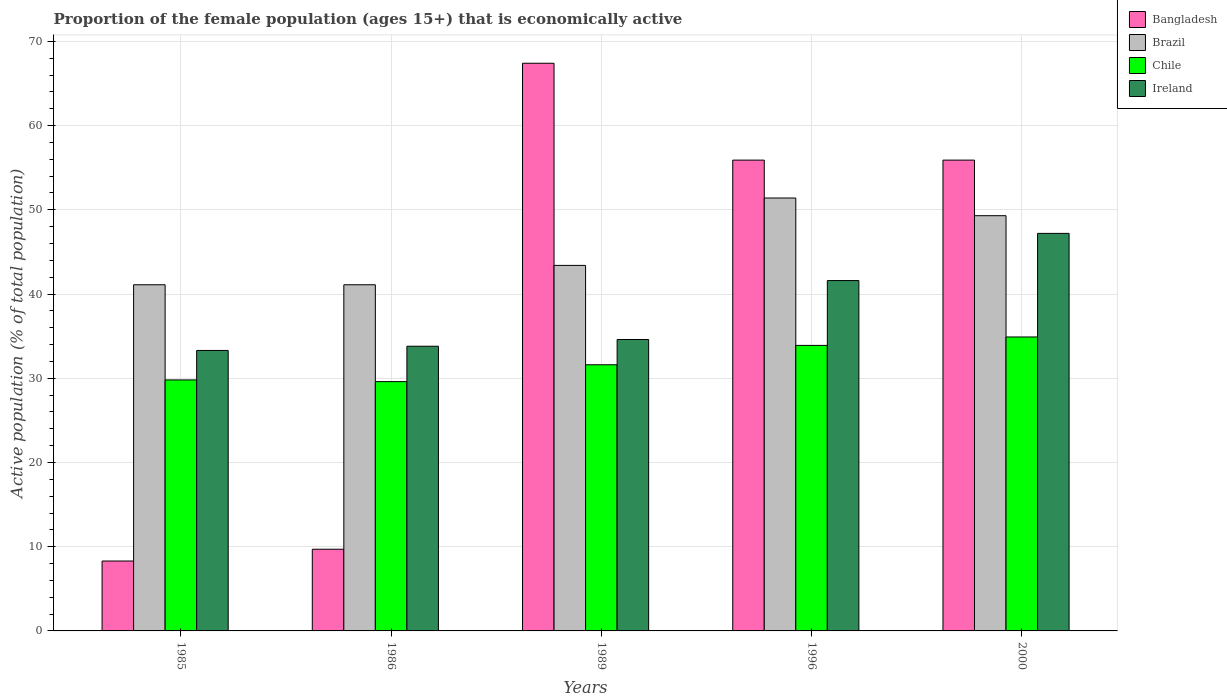How many different coloured bars are there?
Give a very brief answer. 4. How many groups of bars are there?
Your answer should be compact. 5. Are the number of bars on each tick of the X-axis equal?
Offer a terse response. Yes. How many bars are there on the 5th tick from the left?
Provide a short and direct response. 4. What is the proportion of the female population that is economically active in Brazil in 1989?
Give a very brief answer. 43.4. Across all years, what is the maximum proportion of the female population that is economically active in Chile?
Keep it short and to the point. 34.9. Across all years, what is the minimum proportion of the female population that is economically active in Ireland?
Your response must be concise. 33.3. In which year was the proportion of the female population that is economically active in Chile maximum?
Ensure brevity in your answer.  2000. In which year was the proportion of the female population that is economically active in Ireland minimum?
Your answer should be compact. 1985. What is the total proportion of the female population that is economically active in Bangladesh in the graph?
Ensure brevity in your answer.  197.2. What is the difference between the proportion of the female population that is economically active in Brazil in 1989 and that in 2000?
Your response must be concise. -5.9. What is the difference between the proportion of the female population that is economically active in Brazil in 2000 and the proportion of the female population that is economically active in Chile in 1985?
Offer a very short reply. 19.5. What is the average proportion of the female population that is economically active in Brazil per year?
Your answer should be compact. 45.26. In the year 1985, what is the difference between the proportion of the female population that is economically active in Brazil and proportion of the female population that is economically active in Bangladesh?
Provide a succinct answer. 32.8. What is the ratio of the proportion of the female population that is economically active in Brazil in 1985 to that in 1986?
Your response must be concise. 1. Is the proportion of the female population that is economically active in Ireland in 1985 less than that in 1986?
Provide a short and direct response. Yes. What is the difference between the highest and the second highest proportion of the female population that is economically active in Bangladesh?
Make the answer very short. 11.5. What is the difference between the highest and the lowest proportion of the female population that is economically active in Brazil?
Your answer should be very brief. 10.3. Is the sum of the proportion of the female population that is economically active in Brazil in 1985 and 1996 greater than the maximum proportion of the female population that is economically active in Chile across all years?
Your answer should be compact. Yes. What does the 3rd bar from the left in 1985 represents?
Give a very brief answer. Chile. What does the 2nd bar from the right in 1989 represents?
Offer a terse response. Chile. Is it the case that in every year, the sum of the proportion of the female population that is economically active in Chile and proportion of the female population that is economically active in Bangladesh is greater than the proportion of the female population that is economically active in Brazil?
Make the answer very short. No. How many bars are there?
Ensure brevity in your answer.  20. Are all the bars in the graph horizontal?
Keep it short and to the point. No. Does the graph contain grids?
Your response must be concise. Yes. What is the title of the graph?
Your response must be concise. Proportion of the female population (ages 15+) that is economically active. Does "St. Martin (French part)" appear as one of the legend labels in the graph?
Make the answer very short. No. What is the label or title of the X-axis?
Give a very brief answer. Years. What is the label or title of the Y-axis?
Ensure brevity in your answer.  Active population (% of total population). What is the Active population (% of total population) in Bangladesh in 1985?
Make the answer very short. 8.3. What is the Active population (% of total population) in Brazil in 1985?
Give a very brief answer. 41.1. What is the Active population (% of total population) in Chile in 1985?
Make the answer very short. 29.8. What is the Active population (% of total population) of Ireland in 1985?
Provide a short and direct response. 33.3. What is the Active population (% of total population) of Bangladesh in 1986?
Your answer should be compact. 9.7. What is the Active population (% of total population) in Brazil in 1986?
Your answer should be very brief. 41.1. What is the Active population (% of total population) of Chile in 1986?
Your answer should be compact. 29.6. What is the Active population (% of total population) in Ireland in 1986?
Keep it short and to the point. 33.8. What is the Active population (% of total population) in Bangladesh in 1989?
Provide a succinct answer. 67.4. What is the Active population (% of total population) of Brazil in 1989?
Keep it short and to the point. 43.4. What is the Active population (% of total population) in Chile in 1989?
Keep it short and to the point. 31.6. What is the Active population (% of total population) in Ireland in 1989?
Your response must be concise. 34.6. What is the Active population (% of total population) in Bangladesh in 1996?
Keep it short and to the point. 55.9. What is the Active population (% of total population) in Brazil in 1996?
Your answer should be compact. 51.4. What is the Active population (% of total population) in Chile in 1996?
Offer a terse response. 33.9. What is the Active population (% of total population) of Ireland in 1996?
Offer a terse response. 41.6. What is the Active population (% of total population) of Bangladesh in 2000?
Offer a very short reply. 55.9. What is the Active population (% of total population) of Brazil in 2000?
Ensure brevity in your answer.  49.3. What is the Active population (% of total population) in Chile in 2000?
Give a very brief answer. 34.9. What is the Active population (% of total population) of Ireland in 2000?
Make the answer very short. 47.2. Across all years, what is the maximum Active population (% of total population) in Bangladesh?
Make the answer very short. 67.4. Across all years, what is the maximum Active population (% of total population) of Brazil?
Your response must be concise. 51.4. Across all years, what is the maximum Active population (% of total population) of Chile?
Your response must be concise. 34.9. Across all years, what is the maximum Active population (% of total population) in Ireland?
Your response must be concise. 47.2. Across all years, what is the minimum Active population (% of total population) in Bangladesh?
Give a very brief answer. 8.3. Across all years, what is the minimum Active population (% of total population) in Brazil?
Your answer should be very brief. 41.1. Across all years, what is the minimum Active population (% of total population) of Chile?
Give a very brief answer. 29.6. Across all years, what is the minimum Active population (% of total population) in Ireland?
Your answer should be compact. 33.3. What is the total Active population (% of total population) of Bangladesh in the graph?
Offer a terse response. 197.2. What is the total Active population (% of total population) of Brazil in the graph?
Ensure brevity in your answer.  226.3. What is the total Active population (% of total population) of Chile in the graph?
Provide a short and direct response. 159.8. What is the total Active population (% of total population) of Ireland in the graph?
Your answer should be very brief. 190.5. What is the difference between the Active population (% of total population) of Chile in 1985 and that in 1986?
Offer a terse response. 0.2. What is the difference between the Active population (% of total population) of Bangladesh in 1985 and that in 1989?
Your answer should be very brief. -59.1. What is the difference between the Active population (% of total population) of Ireland in 1985 and that in 1989?
Your response must be concise. -1.3. What is the difference between the Active population (% of total population) of Bangladesh in 1985 and that in 1996?
Offer a terse response. -47.6. What is the difference between the Active population (% of total population) of Chile in 1985 and that in 1996?
Offer a very short reply. -4.1. What is the difference between the Active population (% of total population) in Ireland in 1985 and that in 1996?
Your answer should be compact. -8.3. What is the difference between the Active population (% of total population) of Bangladesh in 1985 and that in 2000?
Give a very brief answer. -47.6. What is the difference between the Active population (% of total population) of Chile in 1985 and that in 2000?
Offer a very short reply. -5.1. What is the difference between the Active population (% of total population) in Bangladesh in 1986 and that in 1989?
Provide a short and direct response. -57.7. What is the difference between the Active population (% of total population) of Brazil in 1986 and that in 1989?
Keep it short and to the point. -2.3. What is the difference between the Active population (% of total population) in Bangladesh in 1986 and that in 1996?
Your answer should be compact. -46.2. What is the difference between the Active population (% of total population) in Ireland in 1986 and that in 1996?
Provide a short and direct response. -7.8. What is the difference between the Active population (% of total population) in Bangladesh in 1986 and that in 2000?
Make the answer very short. -46.2. What is the difference between the Active population (% of total population) in Brazil in 1986 and that in 2000?
Provide a succinct answer. -8.2. What is the difference between the Active population (% of total population) of Chile in 1989 and that in 1996?
Give a very brief answer. -2.3. What is the difference between the Active population (% of total population) of Ireland in 1989 and that in 1996?
Your answer should be very brief. -7. What is the difference between the Active population (% of total population) in Bangladesh in 1989 and that in 2000?
Ensure brevity in your answer.  11.5. What is the difference between the Active population (% of total population) in Brazil in 1989 and that in 2000?
Give a very brief answer. -5.9. What is the difference between the Active population (% of total population) of Ireland in 1989 and that in 2000?
Your answer should be very brief. -12.6. What is the difference between the Active population (% of total population) in Bangladesh in 1996 and that in 2000?
Ensure brevity in your answer.  0. What is the difference between the Active population (% of total population) of Chile in 1996 and that in 2000?
Your answer should be compact. -1. What is the difference between the Active population (% of total population) in Ireland in 1996 and that in 2000?
Ensure brevity in your answer.  -5.6. What is the difference between the Active population (% of total population) in Bangladesh in 1985 and the Active population (% of total population) in Brazil in 1986?
Your response must be concise. -32.8. What is the difference between the Active population (% of total population) of Bangladesh in 1985 and the Active population (% of total population) of Chile in 1986?
Offer a very short reply. -21.3. What is the difference between the Active population (% of total population) of Bangladesh in 1985 and the Active population (% of total population) of Ireland in 1986?
Your response must be concise. -25.5. What is the difference between the Active population (% of total population) of Brazil in 1985 and the Active population (% of total population) of Chile in 1986?
Your answer should be compact. 11.5. What is the difference between the Active population (% of total population) of Bangladesh in 1985 and the Active population (% of total population) of Brazil in 1989?
Provide a succinct answer. -35.1. What is the difference between the Active population (% of total population) of Bangladesh in 1985 and the Active population (% of total population) of Chile in 1989?
Offer a terse response. -23.3. What is the difference between the Active population (% of total population) in Bangladesh in 1985 and the Active population (% of total population) in Ireland in 1989?
Give a very brief answer. -26.3. What is the difference between the Active population (% of total population) in Brazil in 1985 and the Active population (% of total population) in Chile in 1989?
Provide a short and direct response. 9.5. What is the difference between the Active population (% of total population) of Brazil in 1985 and the Active population (% of total population) of Ireland in 1989?
Your answer should be very brief. 6.5. What is the difference between the Active population (% of total population) in Chile in 1985 and the Active population (% of total population) in Ireland in 1989?
Keep it short and to the point. -4.8. What is the difference between the Active population (% of total population) of Bangladesh in 1985 and the Active population (% of total population) of Brazil in 1996?
Make the answer very short. -43.1. What is the difference between the Active population (% of total population) in Bangladesh in 1985 and the Active population (% of total population) in Chile in 1996?
Your answer should be very brief. -25.6. What is the difference between the Active population (% of total population) of Bangladesh in 1985 and the Active population (% of total population) of Ireland in 1996?
Your answer should be very brief. -33.3. What is the difference between the Active population (% of total population) of Brazil in 1985 and the Active population (% of total population) of Chile in 1996?
Your answer should be compact. 7.2. What is the difference between the Active population (% of total population) of Brazil in 1985 and the Active population (% of total population) of Ireland in 1996?
Give a very brief answer. -0.5. What is the difference between the Active population (% of total population) of Chile in 1985 and the Active population (% of total population) of Ireland in 1996?
Make the answer very short. -11.8. What is the difference between the Active population (% of total population) of Bangladesh in 1985 and the Active population (% of total population) of Brazil in 2000?
Keep it short and to the point. -41. What is the difference between the Active population (% of total population) of Bangladesh in 1985 and the Active population (% of total population) of Chile in 2000?
Give a very brief answer. -26.6. What is the difference between the Active population (% of total population) in Bangladesh in 1985 and the Active population (% of total population) in Ireland in 2000?
Offer a very short reply. -38.9. What is the difference between the Active population (% of total population) of Brazil in 1985 and the Active population (% of total population) of Ireland in 2000?
Your answer should be compact. -6.1. What is the difference between the Active population (% of total population) in Chile in 1985 and the Active population (% of total population) in Ireland in 2000?
Offer a terse response. -17.4. What is the difference between the Active population (% of total population) of Bangladesh in 1986 and the Active population (% of total population) of Brazil in 1989?
Provide a short and direct response. -33.7. What is the difference between the Active population (% of total population) of Bangladesh in 1986 and the Active population (% of total population) of Chile in 1989?
Provide a short and direct response. -21.9. What is the difference between the Active population (% of total population) of Bangladesh in 1986 and the Active population (% of total population) of Ireland in 1989?
Offer a very short reply. -24.9. What is the difference between the Active population (% of total population) of Brazil in 1986 and the Active population (% of total population) of Ireland in 1989?
Give a very brief answer. 6.5. What is the difference between the Active population (% of total population) in Chile in 1986 and the Active population (% of total population) in Ireland in 1989?
Provide a short and direct response. -5. What is the difference between the Active population (% of total population) in Bangladesh in 1986 and the Active population (% of total population) in Brazil in 1996?
Give a very brief answer. -41.7. What is the difference between the Active population (% of total population) of Bangladesh in 1986 and the Active population (% of total population) of Chile in 1996?
Give a very brief answer. -24.2. What is the difference between the Active population (% of total population) of Bangladesh in 1986 and the Active population (% of total population) of Ireland in 1996?
Offer a terse response. -31.9. What is the difference between the Active population (% of total population) of Brazil in 1986 and the Active population (% of total population) of Chile in 1996?
Your response must be concise. 7.2. What is the difference between the Active population (% of total population) of Bangladesh in 1986 and the Active population (% of total population) of Brazil in 2000?
Give a very brief answer. -39.6. What is the difference between the Active population (% of total population) of Bangladesh in 1986 and the Active population (% of total population) of Chile in 2000?
Keep it short and to the point. -25.2. What is the difference between the Active population (% of total population) of Bangladesh in 1986 and the Active population (% of total population) of Ireland in 2000?
Offer a very short reply. -37.5. What is the difference between the Active population (% of total population) of Brazil in 1986 and the Active population (% of total population) of Chile in 2000?
Make the answer very short. 6.2. What is the difference between the Active population (% of total population) in Chile in 1986 and the Active population (% of total population) in Ireland in 2000?
Keep it short and to the point. -17.6. What is the difference between the Active population (% of total population) in Bangladesh in 1989 and the Active population (% of total population) in Chile in 1996?
Provide a succinct answer. 33.5. What is the difference between the Active population (% of total population) in Bangladesh in 1989 and the Active population (% of total population) in Ireland in 1996?
Your response must be concise. 25.8. What is the difference between the Active population (% of total population) of Brazil in 1989 and the Active population (% of total population) of Chile in 1996?
Give a very brief answer. 9.5. What is the difference between the Active population (% of total population) in Chile in 1989 and the Active population (% of total population) in Ireland in 1996?
Provide a succinct answer. -10. What is the difference between the Active population (% of total population) in Bangladesh in 1989 and the Active population (% of total population) in Chile in 2000?
Your response must be concise. 32.5. What is the difference between the Active population (% of total population) in Bangladesh in 1989 and the Active population (% of total population) in Ireland in 2000?
Offer a very short reply. 20.2. What is the difference between the Active population (% of total population) of Brazil in 1989 and the Active population (% of total population) of Ireland in 2000?
Give a very brief answer. -3.8. What is the difference between the Active population (% of total population) in Chile in 1989 and the Active population (% of total population) in Ireland in 2000?
Ensure brevity in your answer.  -15.6. What is the difference between the Active population (% of total population) of Bangladesh in 1996 and the Active population (% of total population) of Brazil in 2000?
Make the answer very short. 6.6. What is the difference between the Active population (% of total population) in Bangladesh in 1996 and the Active population (% of total population) in Chile in 2000?
Provide a succinct answer. 21. What is the difference between the Active population (% of total population) of Bangladesh in 1996 and the Active population (% of total population) of Ireland in 2000?
Ensure brevity in your answer.  8.7. What is the difference between the Active population (% of total population) in Brazil in 1996 and the Active population (% of total population) in Chile in 2000?
Your answer should be compact. 16.5. What is the difference between the Active population (% of total population) of Brazil in 1996 and the Active population (% of total population) of Ireland in 2000?
Make the answer very short. 4.2. What is the difference between the Active population (% of total population) of Chile in 1996 and the Active population (% of total population) of Ireland in 2000?
Give a very brief answer. -13.3. What is the average Active population (% of total population) in Bangladesh per year?
Provide a succinct answer. 39.44. What is the average Active population (% of total population) of Brazil per year?
Your response must be concise. 45.26. What is the average Active population (% of total population) in Chile per year?
Offer a very short reply. 31.96. What is the average Active population (% of total population) in Ireland per year?
Provide a succinct answer. 38.1. In the year 1985, what is the difference between the Active population (% of total population) of Bangladesh and Active population (% of total population) of Brazil?
Keep it short and to the point. -32.8. In the year 1985, what is the difference between the Active population (% of total population) of Bangladesh and Active population (% of total population) of Chile?
Provide a succinct answer. -21.5. In the year 1985, what is the difference between the Active population (% of total population) of Brazil and Active population (% of total population) of Ireland?
Offer a very short reply. 7.8. In the year 1985, what is the difference between the Active population (% of total population) in Chile and Active population (% of total population) in Ireland?
Offer a terse response. -3.5. In the year 1986, what is the difference between the Active population (% of total population) of Bangladesh and Active population (% of total population) of Brazil?
Your response must be concise. -31.4. In the year 1986, what is the difference between the Active population (% of total population) of Bangladesh and Active population (% of total population) of Chile?
Ensure brevity in your answer.  -19.9. In the year 1986, what is the difference between the Active population (% of total population) in Bangladesh and Active population (% of total population) in Ireland?
Your answer should be compact. -24.1. In the year 1986, what is the difference between the Active population (% of total population) in Brazil and Active population (% of total population) in Ireland?
Offer a terse response. 7.3. In the year 1986, what is the difference between the Active population (% of total population) in Chile and Active population (% of total population) in Ireland?
Provide a short and direct response. -4.2. In the year 1989, what is the difference between the Active population (% of total population) in Bangladesh and Active population (% of total population) in Brazil?
Ensure brevity in your answer.  24. In the year 1989, what is the difference between the Active population (% of total population) in Bangladesh and Active population (% of total population) in Chile?
Offer a terse response. 35.8. In the year 1989, what is the difference between the Active population (% of total population) in Bangladesh and Active population (% of total population) in Ireland?
Your response must be concise. 32.8. In the year 1989, what is the difference between the Active population (% of total population) of Chile and Active population (% of total population) of Ireland?
Make the answer very short. -3. In the year 1996, what is the difference between the Active population (% of total population) of Bangladesh and Active population (% of total population) of Chile?
Keep it short and to the point. 22. In the year 1996, what is the difference between the Active population (% of total population) of Bangladesh and Active population (% of total population) of Ireland?
Ensure brevity in your answer.  14.3. In the year 1996, what is the difference between the Active population (% of total population) of Brazil and Active population (% of total population) of Chile?
Ensure brevity in your answer.  17.5. In the year 1996, what is the difference between the Active population (% of total population) in Chile and Active population (% of total population) in Ireland?
Ensure brevity in your answer.  -7.7. In the year 2000, what is the difference between the Active population (% of total population) of Bangladesh and Active population (% of total population) of Brazil?
Your answer should be very brief. 6.6. In the year 2000, what is the difference between the Active population (% of total population) in Brazil and Active population (% of total population) in Ireland?
Provide a succinct answer. 2.1. In the year 2000, what is the difference between the Active population (% of total population) in Chile and Active population (% of total population) in Ireland?
Provide a succinct answer. -12.3. What is the ratio of the Active population (% of total population) in Bangladesh in 1985 to that in 1986?
Ensure brevity in your answer.  0.86. What is the ratio of the Active population (% of total population) of Chile in 1985 to that in 1986?
Give a very brief answer. 1.01. What is the ratio of the Active population (% of total population) in Ireland in 1985 to that in 1986?
Make the answer very short. 0.99. What is the ratio of the Active population (% of total population) of Bangladesh in 1985 to that in 1989?
Your response must be concise. 0.12. What is the ratio of the Active population (% of total population) of Brazil in 1985 to that in 1989?
Offer a terse response. 0.95. What is the ratio of the Active population (% of total population) in Chile in 1985 to that in 1989?
Give a very brief answer. 0.94. What is the ratio of the Active population (% of total population) of Ireland in 1985 to that in 1989?
Keep it short and to the point. 0.96. What is the ratio of the Active population (% of total population) in Bangladesh in 1985 to that in 1996?
Provide a succinct answer. 0.15. What is the ratio of the Active population (% of total population) of Brazil in 1985 to that in 1996?
Give a very brief answer. 0.8. What is the ratio of the Active population (% of total population) in Chile in 1985 to that in 1996?
Your response must be concise. 0.88. What is the ratio of the Active population (% of total population) of Ireland in 1985 to that in 1996?
Provide a succinct answer. 0.8. What is the ratio of the Active population (% of total population) of Bangladesh in 1985 to that in 2000?
Your response must be concise. 0.15. What is the ratio of the Active population (% of total population) in Brazil in 1985 to that in 2000?
Your answer should be very brief. 0.83. What is the ratio of the Active population (% of total population) of Chile in 1985 to that in 2000?
Provide a succinct answer. 0.85. What is the ratio of the Active population (% of total population) of Ireland in 1985 to that in 2000?
Make the answer very short. 0.71. What is the ratio of the Active population (% of total population) of Bangladesh in 1986 to that in 1989?
Keep it short and to the point. 0.14. What is the ratio of the Active population (% of total population) of Brazil in 1986 to that in 1989?
Offer a terse response. 0.95. What is the ratio of the Active population (% of total population) in Chile in 1986 to that in 1989?
Your response must be concise. 0.94. What is the ratio of the Active population (% of total population) of Ireland in 1986 to that in 1989?
Give a very brief answer. 0.98. What is the ratio of the Active population (% of total population) in Bangladesh in 1986 to that in 1996?
Offer a terse response. 0.17. What is the ratio of the Active population (% of total population) of Brazil in 1986 to that in 1996?
Your response must be concise. 0.8. What is the ratio of the Active population (% of total population) of Chile in 1986 to that in 1996?
Keep it short and to the point. 0.87. What is the ratio of the Active population (% of total population) in Ireland in 1986 to that in 1996?
Your answer should be compact. 0.81. What is the ratio of the Active population (% of total population) of Bangladesh in 1986 to that in 2000?
Your answer should be compact. 0.17. What is the ratio of the Active population (% of total population) in Brazil in 1986 to that in 2000?
Your response must be concise. 0.83. What is the ratio of the Active population (% of total population) in Chile in 1986 to that in 2000?
Provide a succinct answer. 0.85. What is the ratio of the Active population (% of total population) in Ireland in 1986 to that in 2000?
Offer a very short reply. 0.72. What is the ratio of the Active population (% of total population) of Bangladesh in 1989 to that in 1996?
Make the answer very short. 1.21. What is the ratio of the Active population (% of total population) in Brazil in 1989 to that in 1996?
Your answer should be compact. 0.84. What is the ratio of the Active population (% of total population) of Chile in 1989 to that in 1996?
Offer a terse response. 0.93. What is the ratio of the Active population (% of total population) in Ireland in 1989 to that in 1996?
Provide a short and direct response. 0.83. What is the ratio of the Active population (% of total population) in Bangladesh in 1989 to that in 2000?
Keep it short and to the point. 1.21. What is the ratio of the Active population (% of total population) in Brazil in 1989 to that in 2000?
Your response must be concise. 0.88. What is the ratio of the Active population (% of total population) of Chile in 1989 to that in 2000?
Provide a succinct answer. 0.91. What is the ratio of the Active population (% of total population) in Ireland in 1989 to that in 2000?
Make the answer very short. 0.73. What is the ratio of the Active population (% of total population) of Brazil in 1996 to that in 2000?
Provide a short and direct response. 1.04. What is the ratio of the Active population (% of total population) in Chile in 1996 to that in 2000?
Provide a succinct answer. 0.97. What is the ratio of the Active population (% of total population) in Ireland in 1996 to that in 2000?
Offer a very short reply. 0.88. What is the difference between the highest and the second highest Active population (% of total population) in Bangladesh?
Ensure brevity in your answer.  11.5. What is the difference between the highest and the second highest Active population (% of total population) in Brazil?
Provide a succinct answer. 2.1. What is the difference between the highest and the lowest Active population (% of total population) of Bangladesh?
Make the answer very short. 59.1. What is the difference between the highest and the lowest Active population (% of total population) in Brazil?
Provide a short and direct response. 10.3. What is the difference between the highest and the lowest Active population (% of total population) in Ireland?
Your response must be concise. 13.9. 